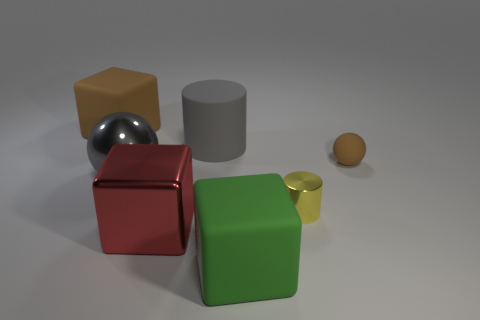Do the small cylinder and the large rubber cylinder have the same color?
Offer a terse response. No. What number of red objects are the same shape as the large brown rubber thing?
Provide a succinct answer. 1. Is the cube that is behind the yellow object made of the same material as the cylinder that is right of the gray rubber thing?
Keep it short and to the point. No. There is a cylinder that is to the right of the gray thing that is behind the tiny rubber sphere; how big is it?
Offer a terse response. Small. Is there anything else that has the same size as the gray matte thing?
Your answer should be very brief. Yes. There is a large red thing that is the same shape as the large green rubber thing; what material is it?
Provide a short and direct response. Metal. There is a large rubber object in front of the yellow metal thing; does it have the same shape as the matte thing behind the gray matte object?
Your answer should be compact. Yes. Is the number of large green things greater than the number of yellow matte spheres?
Your response must be concise. Yes. How big is the metallic sphere?
Provide a short and direct response. Large. How many other objects are there of the same color as the tiny matte ball?
Provide a succinct answer. 1. 